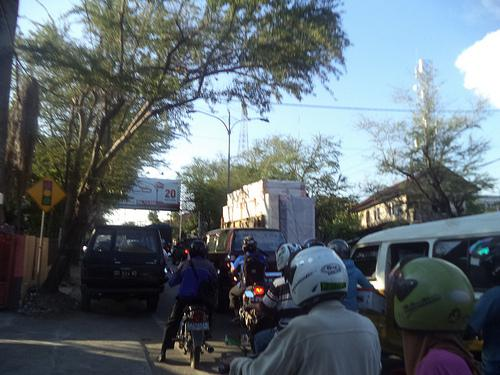Question: when was the picture taken?
Choices:
A. During a traffic jam.
B. At sunset.
C. At sunrise.
D. Middle of afternoon.
Answer with the letter. Answer: A Question: where is the nearest sign?
Choices:
A. The left side of the street.
B. On the corner.
C. On the right side of the street.
D. Overhead.
Answer with the letter. Answer: A Question: why is traffic stopped?
Choices:
A. Stop sign.
B. Red light.
C. Accident.
D. Squirrel in the road.
Answer with the letter. Answer: B Question: how many helmets do you see?
Choices:
A. 7.
B. 8.
C. 2.
D. 3.
Answer with the letter. Answer: B 